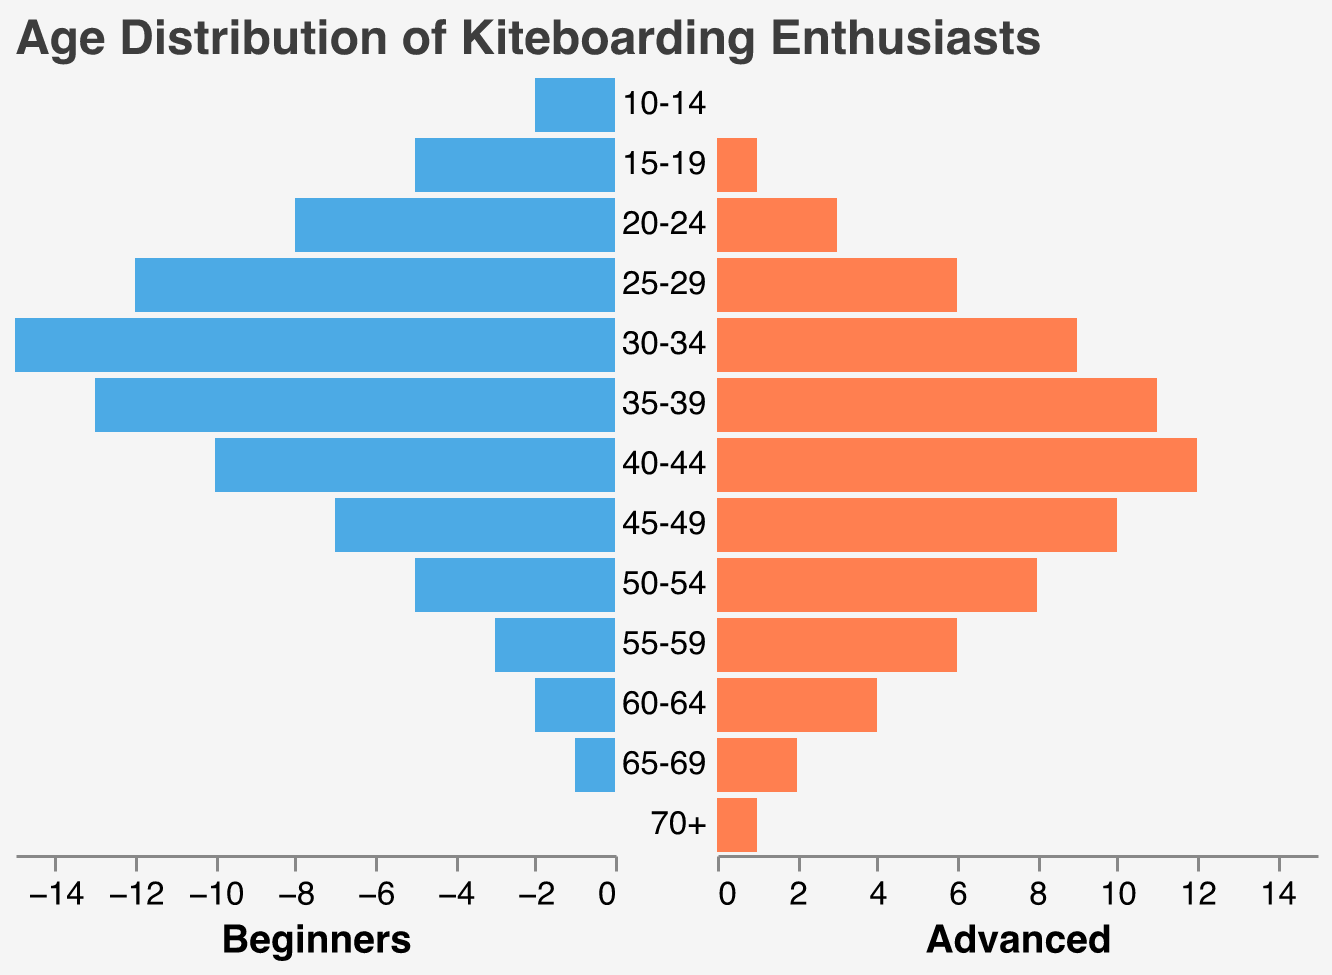What is the title of the figure? The title is usually located at the top of the figure, indicating what the visualization is about.
Answer: Age Distribution of Kiteboarding Enthusiasts Which age group has the highest number of beginners? Look at the left part of the pyramid where the beginners are represented. Identify the bar with the highest value. The age group "30-34" has the tallest bar in the beginners section.
Answer: 30-34 How many age groups have more advanced riders than beginners? Compare the lengths of the bars representing advanced riders and beginners for each age group. Count the instances where the advanced bar is longer.
Answer: 6 What is the total number of beginners aged 25-34? Add the number of beginners in the 25-29 and 30-34 age groups. Beginners in 25-29: 12, Beginners in 30-34: 15. Total = 12 + 15 = 27.
Answer: 27 In which age group do advanced riders start surpassing beginners? Observe the bars for each age group and find the first instance where the advanced riders' bar is taller than the beginners' bar. For the age group "40-44," advanced riders have 12, while beginners have 10.
Answer: 40-44 Which age group has the smallest difference between beginners and advanced riders? Calculate the absolute difference between beginners and advanced riders for each age group and identify the smallest. For "45-49," Beginners: 7, Advanced: 10, Difference = 3 which is the smallest.
Answer: 45-49 What is the difference in the number of riders (advanced) between the 40-44 and 20-24 age groups? Subtract the number of advanced riders in the 20-24 age group from the number of advanced riders in the 40-44 age group. For 40-44: 12, Advanced: 3. Difference = 12 - 3 = 9.
Answer: 9 In which age group is there an equal number of beginners and advanced riders? Compare the lengths of the bars for each age group to find an instance where they are of equal length. For age group "35-39," the number of beginners is 13 and the number of advanced riders is 11. These are close but not equal; none of the groups are exactly equal.
Answer: None 